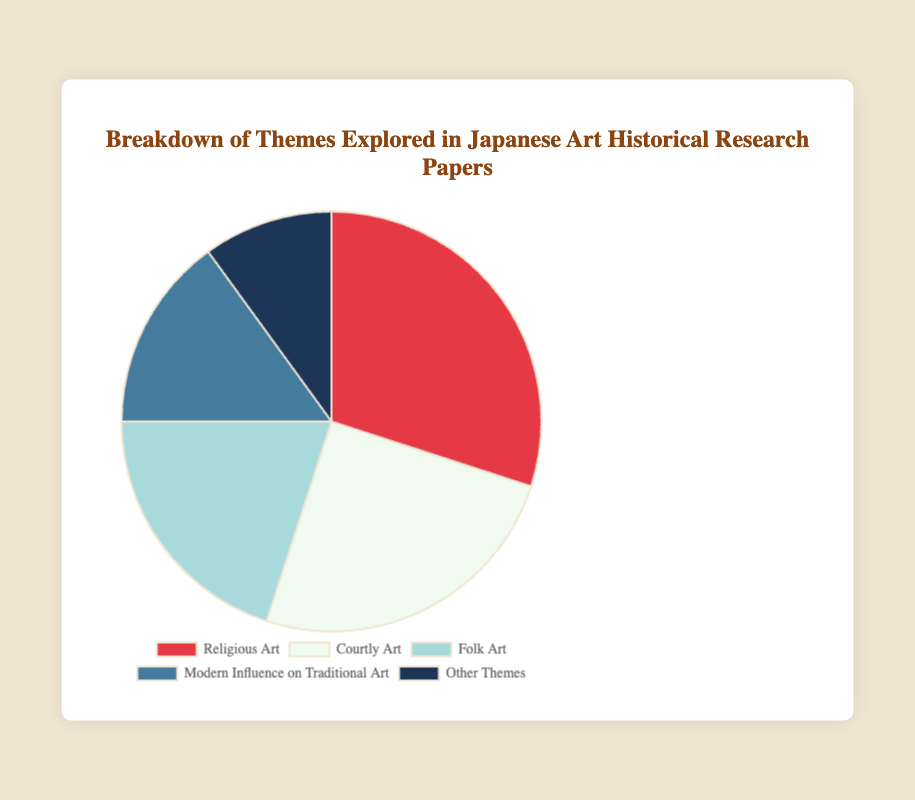What theme accounts for the largest percentage of research papers? The pie chart shows that "Religious Art" has the largest segment, indicating it accounts for the highest percentage.
Answer: Religious Art What is the combined percentage of Courtly Art and Modern Influence on Traditional Art research papers? The percentage for Courtly Art is 25%, and Modern Influence on Traditional Art is 15%. Adding these values gives 25% + 15% = 40%.
Answer: 40% Which theme has a greater percentage of research papers, Folk Art or Other Themes? The chart shows that Folk Art accounts for 20% while Other Themes account for 10%. Therefore, Folk Art has a greater percentage.
Answer: Folk Art How many more percentage points does Religious Art have compared to Folk Art? Religious Art accounts for 30%, and Folk Art accounts for 20%. The difference is 30% - 20% = 10%.
Answer: 10% Which theme is represented by the blue segment in the pie chart? The pie chart's blue segment corresponds to the "Modern Influence on Traditional Art" theme.
Answer: Modern Influence on Traditional Art By what percentage does the theme of Courtly Art surpass the theme of Other Themes? Courtly Art has 25% while Other Themes has 10%. The difference is 25% - 10% = 15%.
Answer: 15% What is the average percentage of the themes excluding the largest and smallest themes? Excluding the largest (Religious Art: 30%) and smallest (Other Themes: 10%), the themes left are Courtly Art (25%), Folk Art (20%), and Modern Influence on Traditional Art (15%). The average is (25% + 20% + 15%) / 3 = 60% / 3 = 20%.
Answer: 20% Which themes combined make up exactly half of all historical research papers? Adding Religious Art (30%) and Folk Art (20%) results in 30% + 20% = 50%, so these two themes combined make up half.
Answer: Religious Art and Folk Art Is the percentage of research papers on Folk Art equal to the percentage of the sum of Post-War Innovation and Contemporary Fusion Art subcategories within Modern Influence on Traditional Art? Folk Art is 20%. Post-War Innovation and Contemporary Fusion Art are 4% and 3% respectively, summing to 4% + 3% = 7%, much less than 20%.
Answer: No 